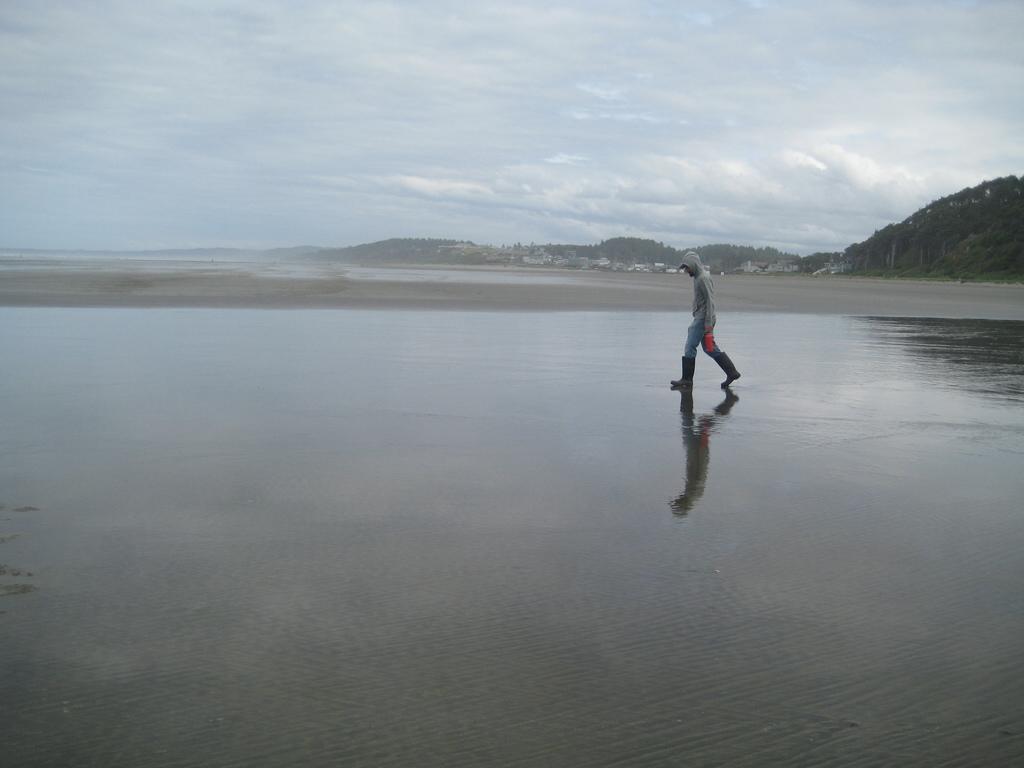In one or two sentences, can you explain what this image depicts? In this image we can see a person standing on a seashore. In the background, we can see a group of buildings, mountains, trees and a cloudy sky. 